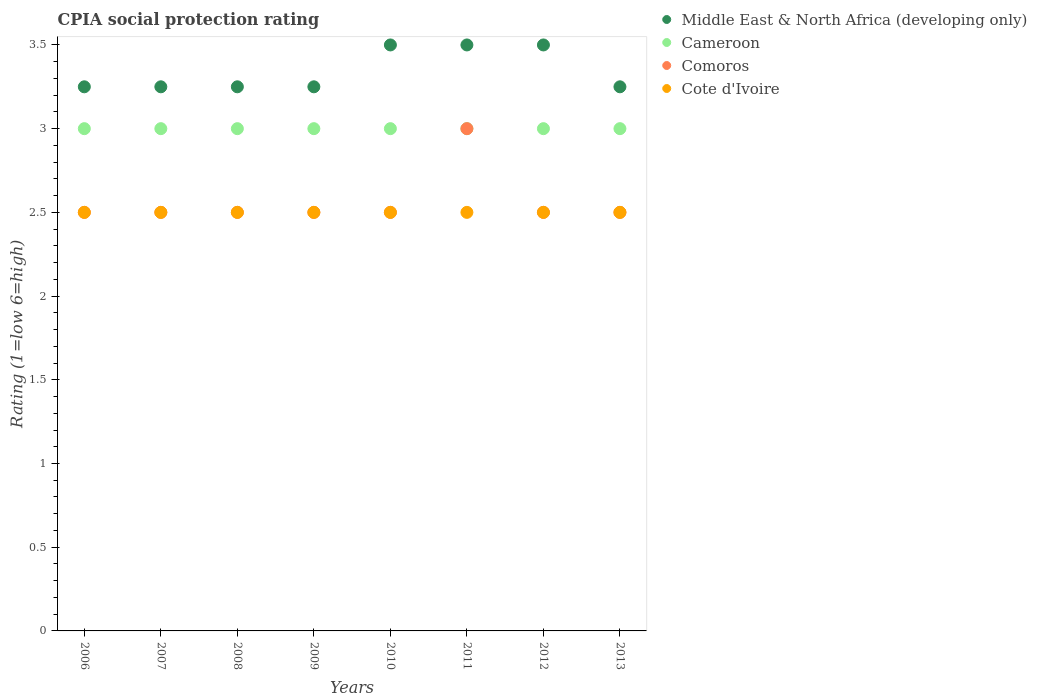How many different coloured dotlines are there?
Make the answer very short. 4. What is the CPIA rating in Middle East & North Africa (developing only) in 2009?
Your response must be concise. 3.25. Across all years, what is the minimum CPIA rating in Cameroon?
Make the answer very short. 3. In which year was the CPIA rating in Cote d'Ivoire maximum?
Give a very brief answer. 2006. In which year was the CPIA rating in Cote d'Ivoire minimum?
Keep it short and to the point. 2006. What is the total CPIA rating in Middle East & North Africa (developing only) in the graph?
Your answer should be compact. 26.75. What is the difference between the CPIA rating in Comoros in 2011 and the CPIA rating in Cote d'Ivoire in 2013?
Your answer should be compact. 0.5. What is the average CPIA rating in Comoros per year?
Provide a succinct answer. 2.56. In the year 2013, what is the difference between the CPIA rating in Comoros and CPIA rating in Middle East & North Africa (developing only)?
Give a very brief answer. -0.75. What is the ratio of the CPIA rating in Comoros in 2007 to that in 2012?
Offer a terse response. 1. Is the CPIA rating in Middle East & North Africa (developing only) in 2007 less than that in 2010?
Your answer should be very brief. Yes. What is the difference between the highest and the second highest CPIA rating in Cote d'Ivoire?
Make the answer very short. 0. What is the difference between the highest and the lowest CPIA rating in Comoros?
Offer a terse response. 0.5. Is it the case that in every year, the sum of the CPIA rating in Comoros and CPIA rating in Cameroon  is greater than the CPIA rating in Cote d'Ivoire?
Offer a terse response. Yes. Is the CPIA rating in Middle East & North Africa (developing only) strictly less than the CPIA rating in Cote d'Ivoire over the years?
Give a very brief answer. No. How many dotlines are there?
Keep it short and to the point. 4. How many years are there in the graph?
Ensure brevity in your answer.  8. Are the values on the major ticks of Y-axis written in scientific E-notation?
Offer a very short reply. No. Does the graph contain any zero values?
Your answer should be very brief. No. Does the graph contain grids?
Offer a very short reply. No. Where does the legend appear in the graph?
Make the answer very short. Top right. How are the legend labels stacked?
Give a very brief answer. Vertical. What is the title of the graph?
Your response must be concise. CPIA social protection rating. Does "Papua New Guinea" appear as one of the legend labels in the graph?
Provide a succinct answer. No. What is the label or title of the X-axis?
Make the answer very short. Years. What is the label or title of the Y-axis?
Your answer should be very brief. Rating (1=low 6=high). What is the Rating (1=low 6=high) of Middle East & North Africa (developing only) in 2006?
Offer a very short reply. 3.25. What is the Rating (1=low 6=high) in Cameroon in 2006?
Offer a very short reply. 3. What is the Rating (1=low 6=high) in Comoros in 2006?
Provide a short and direct response. 2.5. What is the Rating (1=low 6=high) in Cote d'Ivoire in 2006?
Offer a terse response. 2.5. What is the Rating (1=low 6=high) of Middle East & North Africa (developing only) in 2007?
Provide a succinct answer. 3.25. What is the Rating (1=low 6=high) of Cameroon in 2007?
Ensure brevity in your answer.  3. What is the Rating (1=low 6=high) in Comoros in 2007?
Provide a short and direct response. 2.5. What is the Rating (1=low 6=high) of Comoros in 2008?
Ensure brevity in your answer.  2.5. What is the Rating (1=low 6=high) of Middle East & North Africa (developing only) in 2009?
Offer a terse response. 3.25. What is the Rating (1=low 6=high) of Comoros in 2009?
Provide a succinct answer. 2.5. What is the Rating (1=low 6=high) of Cameroon in 2010?
Your response must be concise. 3. What is the Rating (1=low 6=high) in Cote d'Ivoire in 2010?
Your answer should be compact. 2.5. What is the Rating (1=low 6=high) of Middle East & North Africa (developing only) in 2011?
Your response must be concise. 3.5. What is the Rating (1=low 6=high) in Cameroon in 2011?
Make the answer very short. 3. What is the Rating (1=low 6=high) in Middle East & North Africa (developing only) in 2012?
Keep it short and to the point. 3.5. What is the Rating (1=low 6=high) in Cameroon in 2012?
Your response must be concise. 3. What is the Rating (1=low 6=high) of Comoros in 2012?
Your answer should be very brief. 2.5. What is the Rating (1=low 6=high) in Cote d'Ivoire in 2012?
Your answer should be very brief. 2.5. What is the Rating (1=low 6=high) in Cameroon in 2013?
Keep it short and to the point. 3. Across all years, what is the maximum Rating (1=low 6=high) of Middle East & North Africa (developing only)?
Your answer should be very brief. 3.5. Across all years, what is the maximum Rating (1=low 6=high) of Cote d'Ivoire?
Offer a very short reply. 2.5. Across all years, what is the minimum Rating (1=low 6=high) of Middle East & North Africa (developing only)?
Make the answer very short. 3.25. Across all years, what is the minimum Rating (1=low 6=high) of Cameroon?
Make the answer very short. 3. Across all years, what is the minimum Rating (1=low 6=high) of Comoros?
Ensure brevity in your answer.  2.5. What is the total Rating (1=low 6=high) of Middle East & North Africa (developing only) in the graph?
Make the answer very short. 26.75. What is the total Rating (1=low 6=high) in Cameroon in the graph?
Give a very brief answer. 24. What is the total Rating (1=low 6=high) in Comoros in the graph?
Offer a terse response. 20.5. What is the total Rating (1=low 6=high) of Cote d'Ivoire in the graph?
Give a very brief answer. 20. What is the difference between the Rating (1=low 6=high) of Cameroon in 2006 and that in 2007?
Provide a succinct answer. 0. What is the difference between the Rating (1=low 6=high) in Cote d'Ivoire in 2006 and that in 2007?
Offer a very short reply. 0. What is the difference between the Rating (1=low 6=high) of Cameroon in 2006 and that in 2009?
Your answer should be very brief. 0. What is the difference between the Rating (1=low 6=high) in Middle East & North Africa (developing only) in 2006 and that in 2010?
Give a very brief answer. -0.25. What is the difference between the Rating (1=low 6=high) in Comoros in 2006 and that in 2010?
Offer a very short reply. 0. What is the difference between the Rating (1=low 6=high) in Cote d'Ivoire in 2006 and that in 2010?
Your response must be concise. 0. What is the difference between the Rating (1=low 6=high) of Middle East & North Africa (developing only) in 2006 and that in 2011?
Give a very brief answer. -0.25. What is the difference between the Rating (1=low 6=high) in Middle East & North Africa (developing only) in 2006 and that in 2012?
Ensure brevity in your answer.  -0.25. What is the difference between the Rating (1=low 6=high) in Cote d'Ivoire in 2006 and that in 2012?
Provide a short and direct response. 0. What is the difference between the Rating (1=low 6=high) in Middle East & North Africa (developing only) in 2007 and that in 2008?
Give a very brief answer. 0. What is the difference between the Rating (1=low 6=high) of Comoros in 2007 and that in 2008?
Make the answer very short. 0. What is the difference between the Rating (1=low 6=high) in Comoros in 2007 and that in 2010?
Keep it short and to the point. 0. What is the difference between the Rating (1=low 6=high) of Cote d'Ivoire in 2007 and that in 2010?
Ensure brevity in your answer.  0. What is the difference between the Rating (1=low 6=high) in Middle East & North Africa (developing only) in 2007 and that in 2011?
Provide a succinct answer. -0.25. What is the difference between the Rating (1=low 6=high) of Comoros in 2007 and that in 2011?
Ensure brevity in your answer.  -0.5. What is the difference between the Rating (1=low 6=high) in Cote d'Ivoire in 2007 and that in 2011?
Make the answer very short. 0. What is the difference between the Rating (1=low 6=high) in Middle East & North Africa (developing only) in 2007 and that in 2012?
Your answer should be compact. -0.25. What is the difference between the Rating (1=low 6=high) in Comoros in 2007 and that in 2013?
Ensure brevity in your answer.  0. What is the difference between the Rating (1=low 6=high) of Middle East & North Africa (developing only) in 2008 and that in 2009?
Your answer should be very brief. 0. What is the difference between the Rating (1=low 6=high) in Middle East & North Africa (developing only) in 2008 and that in 2010?
Your answer should be compact. -0.25. What is the difference between the Rating (1=low 6=high) in Cote d'Ivoire in 2008 and that in 2010?
Provide a short and direct response. 0. What is the difference between the Rating (1=low 6=high) of Middle East & North Africa (developing only) in 2008 and that in 2011?
Offer a very short reply. -0.25. What is the difference between the Rating (1=low 6=high) of Cameroon in 2008 and that in 2011?
Your answer should be very brief. 0. What is the difference between the Rating (1=low 6=high) in Middle East & North Africa (developing only) in 2008 and that in 2012?
Your answer should be very brief. -0.25. What is the difference between the Rating (1=low 6=high) in Cameroon in 2008 and that in 2012?
Ensure brevity in your answer.  0. What is the difference between the Rating (1=low 6=high) of Middle East & North Africa (developing only) in 2008 and that in 2013?
Provide a succinct answer. 0. What is the difference between the Rating (1=low 6=high) in Comoros in 2008 and that in 2013?
Provide a short and direct response. 0. What is the difference between the Rating (1=low 6=high) of Comoros in 2009 and that in 2010?
Your response must be concise. 0. What is the difference between the Rating (1=low 6=high) in Cote d'Ivoire in 2009 and that in 2011?
Provide a succinct answer. 0. What is the difference between the Rating (1=low 6=high) in Middle East & North Africa (developing only) in 2009 and that in 2012?
Make the answer very short. -0.25. What is the difference between the Rating (1=low 6=high) in Cameroon in 2009 and that in 2012?
Ensure brevity in your answer.  0. What is the difference between the Rating (1=low 6=high) in Comoros in 2009 and that in 2013?
Your answer should be compact. 0. What is the difference between the Rating (1=low 6=high) of Cote d'Ivoire in 2009 and that in 2013?
Give a very brief answer. 0. What is the difference between the Rating (1=low 6=high) in Cameroon in 2010 and that in 2011?
Offer a terse response. 0. What is the difference between the Rating (1=low 6=high) in Cameroon in 2010 and that in 2012?
Offer a very short reply. 0. What is the difference between the Rating (1=low 6=high) in Comoros in 2010 and that in 2012?
Your answer should be compact. 0. What is the difference between the Rating (1=low 6=high) of Cote d'Ivoire in 2010 and that in 2012?
Offer a very short reply. 0. What is the difference between the Rating (1=low 6=high) in Middle East & North Africa (developing only) in 2010 and that in 2013?
Ensure brevity in your answer.  0.25. What is the difference between the Rating (1=low 6=high) of Comoros in 2010 and that in 2013?
Offer a terse response. 0. What is the difference between the Rating (1=low 6=high) in Cote d'Ivoire in 2010 and that in 2013?
Provide a succinct answer. 0. What is the difference between the Rating (1=low 6=high) of Middle East & North Africa (developing only) in 2011 and that in 2012?
Offer a terse response. 0. What is the difference between the Rating (1=low 6=high) of Cameroon in 2011 and that in 2012?
Your answer should be compact. 0. What is the difference between the Rating (1=low 6=high) in Cote d'Ivoire in 2011 and that in 2012?
Make the answer very short. 0. What is the difference between the Rating (1=low 6=high) in Middle East & North Africa (developing only) in 2011 and that in 2013?
Offer a very short reply. 0.25. What is the difference between the Rating (1=low 6=high) of Comoros in 2011 and that in 2013?
Offer a very short reply. 0.5. What is the difference between the Rating (1=low 6=high) in Cameroon in 2012 and that in 2013?
Your response must be concise. 0. What is the difference between the Rating (1=low 6=high) in Comoros in 2012 and that in 2013?
Offer a very short reply. 0. What is the difference between the Rating (1=low 6=high) in Cote d'Ivoire in 2012 and that in 2013?
Offer a terse response. 0. What is the difference between the Rating (1=low 6=high) of Middle East & North Africa (developing only) in 2006 and the Rating (1=low 6=high) of Cameroon in 2007?
Ensure brevity in your answer.  0.25. What is the difference between the Rating (1=low 6=high) of Cameroon in 2006 and the Rating (1=low 6=high) of Comoros in 2007?
Offer a very short reply. 0.5. What is the difference between the Rating (1=low 6=high) of Cameroon in 2006 and the Rating (1=low 6=high) of Cote d'Ivoire in 2007?
Your answer should be very brief. 0.5. What is the difference between the Rating (1=low 6=high) in Middle East & North Africa (developing only) in 2006 and the Rating (1=low 6=high) in Comoros in 2008?
Your answer should be compact. 0.75. What is the difference between the Rating (1=low 6=high) in Middle East & North Africa (developing only) in 2006 and the Rating (1=low 6=high) in Cote d'Ivoire in 2008?
Provide a short and direct response. 0.75. What is the difference between the Rating (1=low 6=high) of Cameroon in 2006 and the Rating (1=low 6=high) of Cote d'Ivoire in 2008?
Your response must be concise. 0.5. What is the difference between the Rating (1=low 6=high) of Comoros in 2006 and the Rating (1=low 6=high) of Cote d'Ivoire in 2008?
Your answer should be compact. 0. What is the difference between the Rating (1=low 6=high) of Middle East & North Africa (developing only) in 2006 and the Rating (1=low 6=high) of Comoros in 2009?
Your response must be concise. 0.75. What is the difference between the Rating (1=low 6=high) in Middle East & North Africa (developing only) in 2006 and the Rating (1=low 6=high) in Cote d'Ivoire in 2009?
Keep it short and to the point. 0.75. What is the difference between the Rating (1=low 6=high) in Cameroon in 2006 and the Rating (1=low 6=high) in Comoros in 2009?
Make the answer very short. 0.5. What is the difference between the Rating (1=low 6=high) in Cameroon in 2006 and the Rating (1=low 6=high) in Cote d'Ivoire in 2009?
Your answer should be very brief. 0.5. What is the difference between the Rating (1=low 6=high) in Middle East & North Africa (developing only) in 2006 and the Rating (1=low 6=high) in Comoros in 2010?
Your answer should be compact. 0.75. What is the difference between the Rating (1=low 6=high) in Cameroon in 2006 and the Rating (1=low 6=high) in Comoros in 2010?
Make the answer very short. 0.5. What is the difference between the Rating (1=low 6=high) of Cameroon in 2006 and the Rating (1=low 6=high) of Comoros in 2011?
Offer a terse response. 0. What is the difference between the Rating (1=low 6=high) in Cameroon in 2006 and the Rating (1=low 6=high) in Cote d'Ivoire in 2011?
Provide a short and direct response. 0.5. What is the difference between the Rating (1=low 6=high) of Comoros in 2006 and the Rating (1=low 6=high) of Cote d'Ivoire in 2011?
Your response must be concise. 0. What is the difference between the Rating (1=low 6=high) of Middle East & North Africa (developing only) in 2006 and the Rating (1=low 6=high) of Cameroon in 2012?
Provide a succinct answer. 0.25. What is the difference between the Rating (1=low 6=high) of Cameroon in 2006 and the Rating (1=low 6=high) of Cote d'Ivoire in 2012?
Your answer should be compact. 0.5. What is the difference between the Rating (1=low 6=high) in Comoros in 2006 and the Rating (1=low 6=high) in Cote d'Ivoire in 2013?
Provide a short and direct response. 0. What is the difference between the Rating (1=low 6=high) of Middle East & North Africa (developing only) in 2007 and the Rating (1=low 6=high) of Cote d'Ivoire in 2008?
Ensure brevity in your answer.  0.75. What is the difference between the Rating (1=low 6=high) of Cameroon in 2007 and the Rating (1=low 6=high) of Cote d'Ivoire in 2008?
Your response must be concise. 0.5. What is the difference between the Rating (1=low 6=high) of Middle East & North Africa (developing only) in 2007 and the Rating (1=low 6=high) of Cameroon in 2009?
Make the answer very short. 0.25. What is the difference between the Rating (1=low 6=high) in Middle East & North Africa (developing only) in 2007 and the Rating (1=low 6=high) in Comoros in 2009?
Your answer should be very brief. 0.75. What is the difference between the Rating (1=low 6=high) in Middle East & North Africa (developing only) in 2007 and the Rating (1=low 6=high) in Cote d'Ivoire in 2009?
Offer a very short reply. 0.75. What is the difference between the Rating (1=low 6=high) in Middle East & North Africa (developing only) in 2007 and the Rating (1=low 6=high) in Cameroon in 2010?
Make the answer very short. 0.25. What is the difference between the Rating (1=low 6=high) of Cameroon in 2007 and the Rating (1=low 6=high) of Cote d'Ivoire in 2010?
Your answer should be compact. 0.5. What is the difference between the Rating (1=low 6=high) in Middle East & North Africa (developing only) in 2007 and the Rating (1=low 6=high) in Cameroon in 2011?
Give a very brief answer. 0.25. What is the difference between the Rating (1=low 6=high) of Cameroon in 2007 and the Rating (1=low 6=high) of Comoros in 2011?
Provide a short and direct response. 0. What is the difference between the Rating (1=low 6=high) in Cameroon in 2007 and the Rating (1=low 6=high) in Cote d'Ivoire in 2011?
Keep it short and to the point. 0.5. What is the difference between the Rating (1=low 6=high) in Comoros in 2007 and the Rating (1=low 6=high) in Cote d'Ivoire in 2011?
Provide a short and direct response. 0. What is the difference between the Rating (1=low 6=high) of Middle East & North Africa (developing only) in 2007 and the Rating (1=low 6=high) of Cote d'Ivoire in 2012?
Your answer should be very brief. 0.75. What is the difference between the Rating (1=low 6=high) in Cameroon in 2007 and the Rating (1=low 6=high) in Comoros in 2012?
Keep it short and to the point. 0.5. What is the difference between the Rating (1=low 6=high) of Comoros in 2007 and the Rating (1=low 6=high) of Cote d'Ivoire in 2012?
Give a very brief answer. 0. What is the difference between the Rating (1=low 6=high) in Middle East & North Africa (developing only) in 2007 and the Rating (1=low 6=high) in Comoros in 2013?
Your response must be concise. 0.75. What is the difference between the Rating (1=low 6=high) in Middle East & North Africa (developing only) in 2007 and the Rating (1=low 6=high) in Cote d'Ivoire in 2013?
Ensure brevity in your answer.  0.75. What is the difference between the Rating (1=low 6=high) in Middle East & North Africa (developing only) in 2008 and the Rating (1=low 6=high) in Cameroon in 2009?
Provide a succinct answer. 0.25. What is the difference between the Rating (1=low 6=high) in Middle East & North Africa (developing only) in 2008 and the Rating (1=low 6=high) in Comoros in 2009?
Provide a short and direct response. 0.75. What is the difference between the Rating (1=low 6=high) in Cameroon in 2008 and the Rating (1=low 6=high) in Comoros in 2009?
Your answer should be compact. 0.5. What is the difference between the Rating (1=low 6=high) of Cameroon in 2008 and the Rating (1=low 6=high) of Cote d'Ivoire in 2009?
Your answer should be compact. 0.5. What is the difference between the Rating (1=low 6=high) in Middle East & North Africa (developing only) in 2008 and the Rating (1=low 6=high) in Cameroon in 2010?
Your answer should be compact. 0.25. What is the difference between the Rating (1=low 6=high) in Middle East & North Africa (developing only) in 2008 and the Rating (1=low 6=high) in Cote d'Ivoire in 2010?
Provide a succinct answer. 0.75. What is the difference between the Rating (1=low 6=high) of Cameroon in 2008 and the Rating (1=low 6=high) of Comoros in 2010?
Your answer should be very brief. 0.5. What is the difference between the Rating (1=low 6=high) in Middle East & North Africa (developing only) in 2008 and the Rating (1=low 6=high) in Cameroon in 2011?
Your answer should be compact. 0.25. What is the difference between the Rating (1=low 6=high) of Middle East & North Africa (developing only) in 2008 and the Rating (1=low 6=high) of Comoros in 2011?
Your answer should be compact. 0.25. What is the difference between the Rating (1=low 6=high) of Middle East & North Africa (developing only) in 2008 and the Rating (1=low 6=high) of Cameroon in 2012?
Provide a short and direct response. 0.25. What is the difference between the Rating (1=low 6=high) in Middle East & North Africa (developing only) in 2008 and the Rating (1=low 6=high) in Cote d'Ivoire in 2012?
Offer a very short reply. 0.75. What is the difference between the Rating (1=low 6=high) of Cameroon in 2008 and the Rating (1=low 6=high) of Cote d'Ivoire in 2012?
Your response must be concise. 0.5. What is the difference between the Rating (1=low 6=high) of Comoros in 2008 and the Rating (1=low 6=high) of Cote d'Ivoire in 2012?
Offer a very short reply. 0. What is the difference between the Rating (1=low 6=high) of Middle East & North Africa (developing only) in 2008 and the Rating (1=low 6=high) of Comoros in 2013?
Offer a very short reply. 0.75. What is the difference between the Rating (1=low 6=high) in Comoros in 2008 and the Rating (1=low 6=high) in Cote d'Ivoire in 2013?
Keep it short and to the point. 0. What is the difference between the Rating (1=low 6=high) in Middle East & North Africa (developing only) in 2009 and the Rating (1=low 6=high) in Cameroon in 2010?
Make the answer very short. 0.25. What is the difference between the Rating (1=low 6=high) of Middle East & North Africa (developing only) in 2009 and the Rating (1=low 6=high) of Comoros in 2010?
Your response must be concise. 0.75. What is the difference between the Rating (1=low 6=high) of Middle East & North Africa (developing only) in 2009 and the Rating (1=low 6=high) of Cote d'Ivoire in 2010?
Your answer should be very brief. 0.75. What is the difference between the Rating (1=low 6=high) of Cameroon in 2009 and the Rating (1=low 6=high) of Comoros in 2010?
Make the answer very short. 0.5. What is the difference between the Rating (1=low 6=high) in Cameroon in 2009 and the Rating (1=low 6=high) in Cote d'Ivoire in 2010?
Your response must be concise. 0.5. What is the difference between the Rating (1=low 6=high) in Comoros in 2009 and the Rating (1=low 6=high) in Cote d'Ivoire in 2010?
Ensure brevity in your answer.  0. What is the difference between the Rating (1=low 6=high) of Middle East & North Africa (developing only) in 2009 and the Rating (1=low 6=high) of Cameroon in 2011?
Ensure brevity in your answer.  0.25. What is the difference between the Rating (1=low 6=high) of Middle East & North Africa (developing only) in 2009 and the Rating (1=low 6=high) of Cote d'Ivoire in 2011?
Give a very brief answer. 0.75. What is the difference between the Rating (1=low 6=high) of Cameroon in 2009 and the Rating (1=low 6=high) of Cote d'Ivoire in 2011?
Provide a short and direct response. 0.5. What is the difference between the Rating (1=low 6=high) of Comoros in 2009 and the Rating (1=low 6=high) of Cote d'Ivoire in 2011?
Make the answer very short. 0. What is the difference between the Rating (1=low 6=high) in Middle East & North Africa (developing only) in 2009 and the Rating (1=low 6=high) in Cameroon in 2012?
Provide a succinct answer. 0.25. What is the difference between the Rating (1=low 6=high) in Middle East & North Africa (developing only) in 2009 and the Rating (1=low 6=high) in Comoros in 2012?
Keep it short and to the point. 0.75. What is the difference between the Rating (1=low 6=high) of Middle East & North Africa (developing only) in 2009 and the Rating (1=low 6=high) of Cote d'Ivoire in 2012?
Your response must be concise. 0.75. What is the difference between the Rating (1=low 6=high) in Comoros in 2009 and the Rating (1=low 6=high) in Cote d'Ivoire in 2012?
Your answer should be very brief. 0. What is the difference between the Rating (1=low 6=high) in Middle East & North Africa (developing only) in 2009 and the Rating (1=low 6=high) in Comoros in 2013?
Offer a terse response. 0.75. What is the difference between the Rating (1=low 6=high) in Middle East & North Africa (developing only) in 2009 and the Rating (1=low 6=high) in Cote d'Ivoire in 2013?
Your answer should be very brief. 0.75. What is the difference between the Rating (1=low 6=high) in Cameroon in 2009 and the Rating (1=low 6=high) in Cote d'Ivoire in 2013?
Ensure brevity in your answer.  0.5. What is the difference between the Rating (1=low 6=high) in Middle East & North Africa (developing only) in 2010 and the Rating (1=low 6=high) in Cameroon in 2011?
Offer a terse response. 0.5. What is the difference between the Rating (1=low 6=high) in Middle East & North Africa (developing only) in 2010 and the Rating (1=low 6=high) in Cote d'Ivoire in 2011?
Offer a terse response. 1. What is the difference between the Rating (1=low 6=high) in Cameroon in 2010 and the Rating (1=low 6=high) in Cote d'Ivoire in 2011?
Your response must be concise. 0.5. What is the difference between the Rating (1=low 6=high) in Middle East & North Africa (developing only) in 2010 and the Rating (1=low 6=high) in Cameroon in 2012?
Offer a terse response. 0.5. What is the difference between the Rating (1=low 6=high) of Cameroon in 2010 and the Rating (1=low 6=high) of Comoros in 2012?
Provide a short and direct response. 0.5. What is the difference between the Rating (1=low 6=high) in Comoros in 2010 and the Rating (1=low 6=high) in Cote d'Ivoire in 2012?
Your answer should be very brief. 0. What is the difference between the Rating (1=low 6=high) of Middle East & North Africa (developing only) in 2010 and the Rating (1=low 6=high) of Cote d'Ivoire in 2013?
Provide a short and direct response. 1. What is the difference between the Rating (1=low 6=high) in Cameroon in 2010 and the Rating (1=low 6=high) in Cote d'Ivoire in 2013?
Offer a terse response. 0.5. What is the difference between the Rating (1=low 6=high) of Comoros in 2010 and the Rating (1=low 6=high) of Cote d'Ivoire in 2013?
Your response must be concise. 0. What is the difference between the Rating (1=low 6=high) in Middle East & North Africa (developing only) in 2011 and the Rating (1=low 6=high) in Cameroon in 2012?
Keep it short and to the point. 0.5. What is the difference between the Rating (1=low 6=high) in Middle East & North Africa (developing only) in 2011 and the Rating (1=low 6=high) in Comoros in 2012?
Your answer should be compact. 1. What is the difference between the Rating (1=low 6=high) in Middle East & North Africa (developing only) in 2011 and the Rating (1=low 6=high) in Cote d'Ivoire in 2012?
Provide a succinct answer. 1. What is the difference between the Rating (1=low 6=high) in Cameroon in 2011 and the Rating (1=low 6=high) in Comoros in 2012?
Give a very brief answer. 0.5. What is the difference between the Rating (1=low 6=high) of Comoros in 2011 and the Rating (1=low 6=high) of Cote d'Ivoire in 2012?
Give a very brief answer. 0.5. What is the difference between the Rating (1=low 6=high) in Middle East & North Africa (developing only) in 2011 and the Rating (1=low 6=high) in Cameroon in 2013?
Make the answer very short. 0.5. What is the difference between the Rating (1=low 6=high) of Middle East & North Africa (developing only) in 2011 and the Rating (1=low 6=high) of Comoros in 2013?
Provide a short and direct response. 1. What is the difference between the Rating (1=low 6=high) of Middle East & North Africa (developing only) in 2011 and the Rating (1=low 6=high) of Cote d'Ivoire in 2013?
Your answer should be compact. 1. What is the difference between the Rating (1=low 6=high) of Cameroon in 2011 and the Rating (1=low 6=high) of Comoros in 2013?
Provide a succinct answer. 0.5. What is the difference between the Rating (1=low 6=high) of Cameroon in 2012 and the Rating (1=low 6=high) of Comoros in 2013?
Provide a succinct answer. 0.5. What is the difference between the Rating (1=low 6=high) in Cameroon in 2012 and the Rating (1=low 6=high) in Cote d'Ivoire in 2013?
Provide a succinct answer. 0.5. What is the difference between the Rating (1=low 6=high) of Comoros in 2012 and the Rating (1=low 6=high) of Cote d'Ivoire in 2013?
Offer a very short reply. 0. What is the average Rating (1=low 6=high) of Middle East & North Africa (developing only) per year?
Offer a very short reply. 3.34. What is the average Rating (1=low 6=high) in Cameroon per year?
Your response must be concise. 3. What is the average Rating (1=low 6=high) of Comoros per year?
Provide a succinct answer. 2.56. In the year 2006, what is the difference between the Rating (1=low 6=high) of Middle East & North Africa (developing only) and Rating (1=low 6=high) of Cameroon?
Provide a succinct answer. 0.25. In the year 2006, what is the difference between the Rating (1=low 6=high) of Middle East & North Africa (developing only) and Rating (1=low 6=high) of Comoros?
Provide a succinct answer. 0.75. In the year 2006, what is the difference between the Rating (1=low 6=high) in Cameroon and Rating (1=low 6=high) in Comoros?
Give a very brief answer. 0.5. In the year 2006, what is the difference between the Rating (1=low 6=high) of Cameroon and Rating (1=low 6=high) of Cote d'Ivoire?
Keep it short and to the point. 0.5. In the year 2007, what is the difference between the Rating (1=low 6=high) of Middle East & North Africa (developing only) and Rating (1=low 6=high) of Cameroon?
Provide a short and direct response. 0.25. In the year 2007, what is the difference between the Rating (1=low 6=high) in Middle East & North Africa (developing only) and Rating (1=low 6=high) in Cote d'Ivoire?
Give a very brief answer. 0.75. In the year 2007, what is the difference between the Rating (1=low 6=high) of Comoros and Rating (1=low 6=high) of Cote d'Ivoire?
Provide a short and direct response. 0. In the year 2008, what is the difference between the Rating (1=low 6=high) of Middle East & North Africa (developing only) and Rating (1=low 6=high) of Comoros?
Ensure brevity in your answer.  0.75. In the year 2008, what is the difference between the Rating (1=low 6=high) of Middle East & North Africa (developing only) and Rating (1=low 6=high) of Cote d'Ivoire?
Your answer should be very brief. 0.75. In the year 2008, what is the difference between the Rating (1=low 6=high) of Cameroon and Rating (1=low 6=high) of Comoros?
Make the answer very short. 0.5. In the year 2008, what is the difference between the Rating (1=low 6=high) of Cameroon and Rating (1=low 6=high) of Cote d'Ivoire?
Your answer should be very brief. 0.5. In the year 2009, what is the difference between the Rating (1=low 6=high) of Middle East & North Africa (developing only) and Rating (1=low 6=high) of Comoros?
Your answer should be compact. 0.75. In the year 2009, what is the difference between the Rating (1=low 6=high) in Middle East & North Africa (developing only) and Rating (1=low 6=high) in Cote d'Ivoire?
Your response must be concise. 0.75. In the year 2010, what is the difference between the Rating (1=low 6=high) of Middle East & North Africa (developing only) and Rating (1=low 6=high) of Cameroon?
Provide a succinct answer. 0.5. In the year 2011, what is the difference between the Rating (1=low 6=high) of Middle East & North Africa (developing only) and Rating (1=low 6=high) of Comoros?
Ensure brevity in your answer.  0.5. In the year 2011, what is the difference between the Rating (1=low 6=high) of Middle East & North Africa (developing only) and Rating (1=low 6=high) of Cote d'Ivoire?
Make the answer very short. 1. In the year 2011, what is the difference between the Rating (1=low 6=high) in Cameroon and Rating (1=low 6=high) in Comoros?
Provide a short and direct response. 0. In the year 2012, what is the difference between the Rating (1=low 6=high) in Cameroon and Rating (1=low 6=high) in Cote d'Ivoire?
Offer a very short reply. 0.5. In the year 2012, what is the difference between the Rating (1=low 6=high) in Comoros and Rating (1=low 6=high) in Cote d'Ivoire?
Your answer should be very brief. 0. In the year 2013, what is the difference between the Rating (1=low 6=high) in Middle East & North Africa (developing only) and Rating (1=low 6=high) in Cameroon?
Your answer should be compact. 0.25. In the year 2013, what is the difference between the Rating (1=low 6=high) in Middle East & North Africa (developing only) and Rating (1=low 6=high) in Cote d'Ivoire?
Give a very brief answer. 0.75. In the year 2013, what is the difference between the Rating (1=low 6=high) of Comoros and Rating (1=low 6=high) of Cote d'Ivoire?
Your answer should be compact. 0. What is the ratio of the Rating (1=low 6=high) in Cameroon in 2006 to that in 2007?
Provide a short and direct response. 1. What is the ratio of the Rating (1=low 6=high) in Comoros in 2006 to that in 2007?
Your answer should be very brief. 1. What is the ratio of the Rating (1=low 6=high) of Middle East & North Africa (developing only) in 2006 to that in 2008?
Offer a terse response. 1. What is the ratio of the Rating (1=low 6=high) in Cameroon in 2006 to that in 2008?
Make the answer very short. 1. What is the ratio of the Rating (1=low 6=high) of Comoros in 2006 to that in 2008?
Offer a very short reply. 1. What is the ratio of the Rating (1=low 6=high) in Middle East & North Africa (developing only) in 2006 to that in 2009?
Your answer should be compact. 1. What is the ratio of the Rating (1=low 6=high) in Cameroon in 2006 to that in 2009?
Your answer should be very brief. 1. What is the ratio of the Rating (1=low 6=high) in Cote d'Ivoire in 2006 to that in 2009?
Offer a terse response. 1. What is the ratio of the Rating (1=low 6=high) of Cameroon in 2006 to that in 2010?
Your answer should be compact. 1. What is the ratio of the Rating (1=low 6=high) in Middle East & North Africa (developing only) in 2006 to that in 2011?
Your answer should be very brief. 0.93. What is the ratio of the Rating (1=low 6=high) of Cote d'Ivoire in 2006 to that in 2011?
Give a very brief answer. 1. What is the ratio of the Rating (1=low 6=high) in Cameroon in 2006 to that in 2012?
Ensure brevity in your answer.  1. What is the ratio of the Rating (1=low 6=high) in Comoros in 2006 to that in 2013?
Give a very brief answer. 1. What is the ratio of the Rating (1=low 6=high) of Cote d'Ivoire in 2006 to that in 2013?
Your response must be concise. 1. What is the ratio of the Rating (1=low 6=high) of Comoros in 2007 to that in 2008?
Give a very brief answer. 1. What is the ratio of the Rating (1=low 6=high) of Comoros in 2007 to that in 2009?
Your answer should be very brief. 1. What is the ratio of the Rating (1=low 6=high) in Middle East & North Africa (developing only) in 2007 to that in 2010?
Offer a very short reply. 0.93. What is the ratio of the Rating (1=low 6=high) in Cameroon in 2007 to that in 2010?
Your answer should be very brief. 1. What is the ratio of the Rating (1=low 6=high) of Cote d'Ivoire in 2007 to that in 2010?
Provide a short and direct response. 1. What is the ratio of the Rating (1=low 6=high) of Middle East & North Africa (developing only) in 2007 to that in 2011?
Keep it short and to the point. 0.93. What is the ratio of the Rating (1=low 6=high) of Cameroon in 2007 to that in 2011?
Provide a succinct answer. 1. What is the ratio of the Rating (1=low 6=high) in Comoros in 2007 to that in 2011?
Give a very brief answer. 0.83. What is the ratio of the Rating (1=low 6=high) in Cote d'Ivoire in 2007 to that in 2011?
Give a very brief answer. 1. What is the ratio of the Rating (1=low 6=high) of Middle East & North Africa (developing only) in 2007 to that in 2013?
Give a very brief answer. 1. What is the ratio of the Rating (1=low 6=high) of Comoros in 2007 to that in 2013?
Your answer should be very brief. 1. What is the ratio of the Rating (1=low 6=high) in Cote d'Ivoire in 2007 to that in 2013?
Ensure brevity in your answer.  1. What is the ratio of the Rating (1=low 6=high) in Middle East & North Africa (developing only) in 2008 to that in 2009?
Make the answer very short. 1. What is the ratio of the Rating (1=low 6=high) in Comoros in 2008 to that in 2009?
Keep it short and to the point. 1. What is the ratio of the Rating (1=low 6=high) in Middle East & North Africa (developing only) in 2008 to that in 2010?
Offer a very short reply. 0.93. What is the ratio of the Rating (1=low 6=high) of Cameroon in 2008 to that in 2010?
Your answer should be very brief. 1. What is the ratio of the Rating (1=low 6=high) of Comoros in 2008 to that in 2010?
Your answer should be compact. 1. What is the ratio of the Rating (1=low 6=high) in Cote d'Ivoire in 2008 to that in 2010?
Ensure brevity in your answer.  1. What is the ratio of the Rating (1=low 6=high) of Comoros in 2008 to that in 2011?
Provide a short and direct response. 0.83. What is the ratio of the Rating (1=low 6=high) in Middle East & North Africa (developing only) in 2008 to that in 2012?
Your response must be concise. 0.93. What is the ratio of the Rating (1=low 6=high) in Comoros in 2008 to that in 2013?
Your response must be concise. 1. What is the ratio of the Rating (1=low 6=high) of Cote d'Ivoire in 2008 to that in 2013?
Make the answer very short. 1. What is the ratio of the Rating (1=low 6=high) in Cameroon in 2009 to that in 2010?
Keep it short and to the point. 1. What is the ratio of the Rating (1=low 6=high) in Middle East & North Africa (developing only) in 2009 to that in 2011?
Offer a very short reply. 0.93. What is the ratio of the Rating (1=low 6=high) in Cameroon in 2009 to that in 2011?
Offer a terse response. 1. What is the ratio of the Rating (1=low 6=high) in Comoros in 2009 to that in 2011?
Your answer should be very brief. 0.83. What is the ratio of the Rating (1=low 6=high) of Cote d'Ivoire in 2009 to that in 2011?
Make the answer very short. 1. What is the ratio of the Rating (1=low 6=high) in Cameroon in 2009 to that in 2012?
Your response must be concise. 1. What is the ratio of the Rating (1=low 6=high) of Middle East & North Africa (developing only) in 2009 to that in 2013?
Your answer should be compact. 1. What is the ratio of the Rating (1=low 6=high) in Cote d'Ivoire in 2009 to that in 2013?
Offer a terse response. 1. What is the ratio of the Rating (1=low 6=high) of Cameroon in 2010 to that in 2011?
Your answer should be very brief. 1. What is the ratio of the Rating (1=low 6=high) in Comoros in 2010 to that in 2011?
Make the answer very short. 0.83. What is the ratio of the Rating (1=low 6=high) in Cote d'Ivoire in 2010 to that in 2011?
Your response must be concise. 1. What is the ratio of the Rating (1=low 6=high) of Cameroon in 2010 to that in 2012?
Offer a terse response. 1. What is the ratio of the Rating (1=low 6=high) in Cameroon in 2010 to that in 2013?
Keep it short and to the point. 1. What is the ratio of the Rating (1=low 6=high) in Comoros in 2010 to that in 2013?
Make the answer very short. 1. What is the ratio of the Rating (1=low 6=high) in Cote d'Ivoire in 2010 to that in 2013?
Offer a very short reply. 1. What is the ratio of the Rating (1=low 6=high) of Middle East & North Africa (developing only) in 2011 to that in 2012?
Your response must be concise. 1. What is the ratio of the Rating (1=low 6=high) of Cote d'Ivoire in 2011 to that in 2012?
Give a very brief answer. 1. What is the ratio of the Rating (1=low 6=high) of Middle East & North Africa (developing only) in 2011 to that in 2013?
Provide a short and direct response. 1.08. What is the ratio of the Rating (1=low 6=high) in Cameroon in 2011 to that in 2013?
Your response must be concise. 1. What is the ratio of the Rating (1=low 6=high) of Comoros in 2011 to that in 2013?
Keep it short and to the point. 1.2. What is the ratio of the Rating (1=low 6=high) in Cote d'Ivoire in 2011 to that in 2013?
Your response must be concise. 1. What is the ratio of the Rating (1=low 6=high) of Cameroon in 2012 to that in 2013?
Your answer should be very brief. 1. What is the ratio of the Rating (1=low 6=high) in Comoros in 2012 to that in 2013?
Ensure brevity in your answer.  1. What is the ratio of the Rating (1=low 6=high) in Cote d'Ivoire in 2012 to that in 2013?
Provide a short and direct response. 1. What is the difference between the highest and the second highest Rating (1=low 6=high) of Cote d'Ivoire?
Provide a short and direct response. 0. What is the difference between the highest and the lowest Rating (1=low 6=high) in Cote d'Ivoire?
Offer a very short reply. 0. 